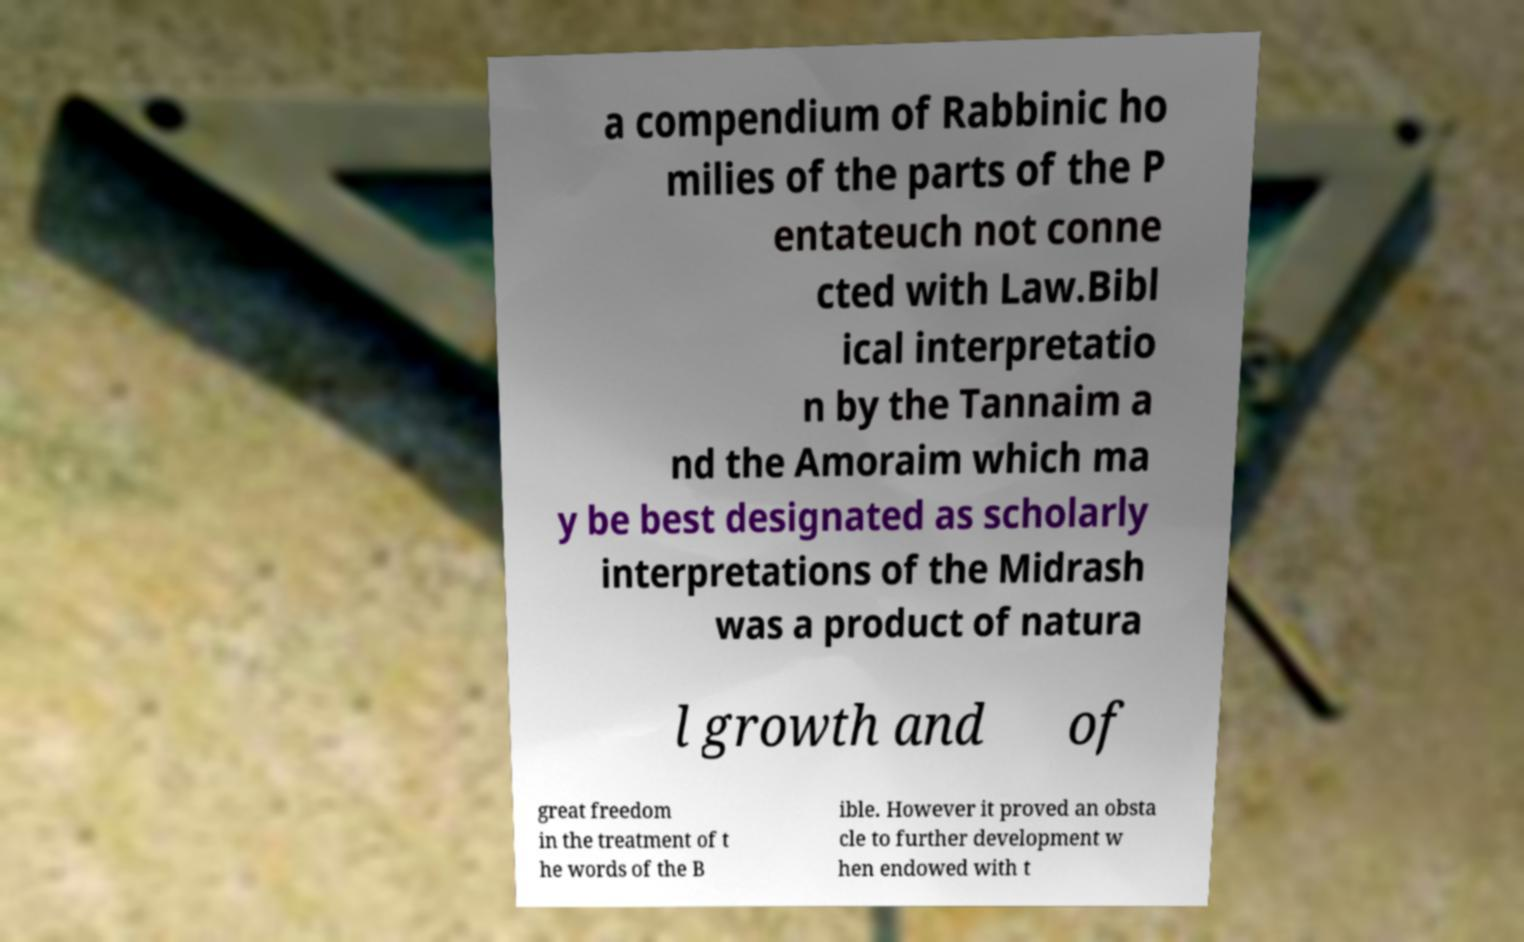Could you extract and type out the text from this image? a compendium of Rabbinic ho milies of the parts of the P entateuch not conne cted with Law.Bibl ical interpretatio n by the Tannaim a nd the Amoraim which ma y be best designated as scholarly interpretations of the Midrash was a product of natura l growth and of great freedom in the treatment of t he words of the B ible. However it proved an obsta cle to further development w hen endowed with t 